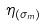Convert formula to latex. <formula><loc_0><loc_0><loc_500><loc_500>\eta _ { ( \sigma _ { m } ) }</formula> 